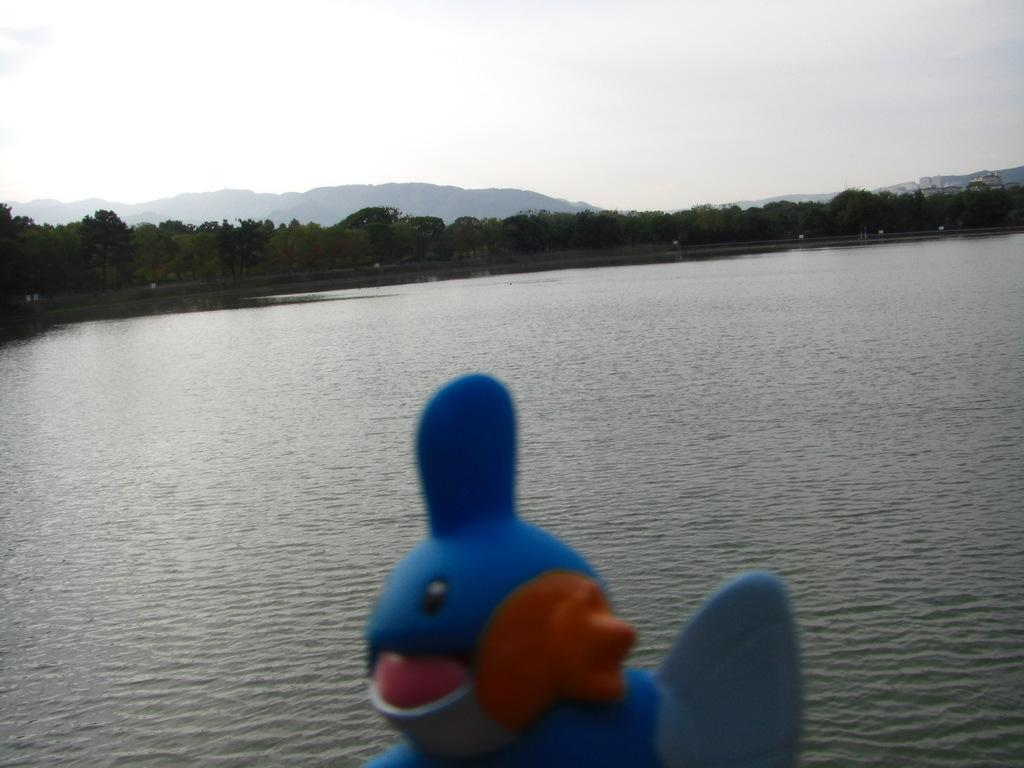What object is located in the front of the image? There is a toy in the front of the image. What is present at the bottom of the image? There is water at the bottom of the image. What type of vegetation can be seen in the background of the image? There are trees in the background of the image. What is visible at the top of the image? The sky is visible at the top of the image. What type of tramp is visible in the image? There is no tramp present in the image. How does the heart shape appear in the image? There is no heart shape present in the image. 